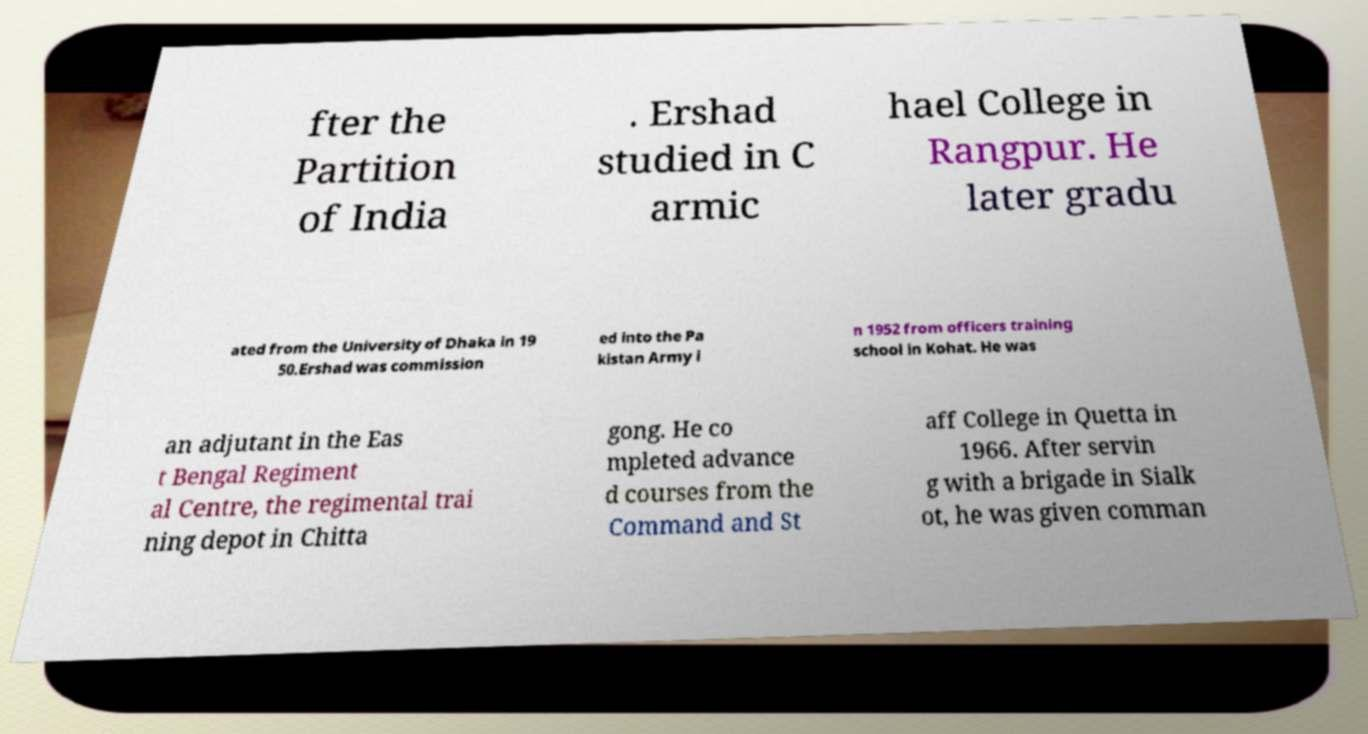There's text embedded in this image that I need extracted. Can you transcribe it verbatim? fter the Partition of India . Ershad studied in C armic hael College in Rangpur. He later gradu ated from the University of Dhaka in 19 50.Ershad was commission ed into the Pa kistan Army i n 1952 from officers training school in Kohat. He was an adjutant in the Eas t Bengal Regiment al Centre, the regimental trai ning depot in Chitta gong. He co mpleted advance d courses from the Command and St aff College in Quetta in 1966. After servin g with a brigade in Sialk ot, he was given comman 